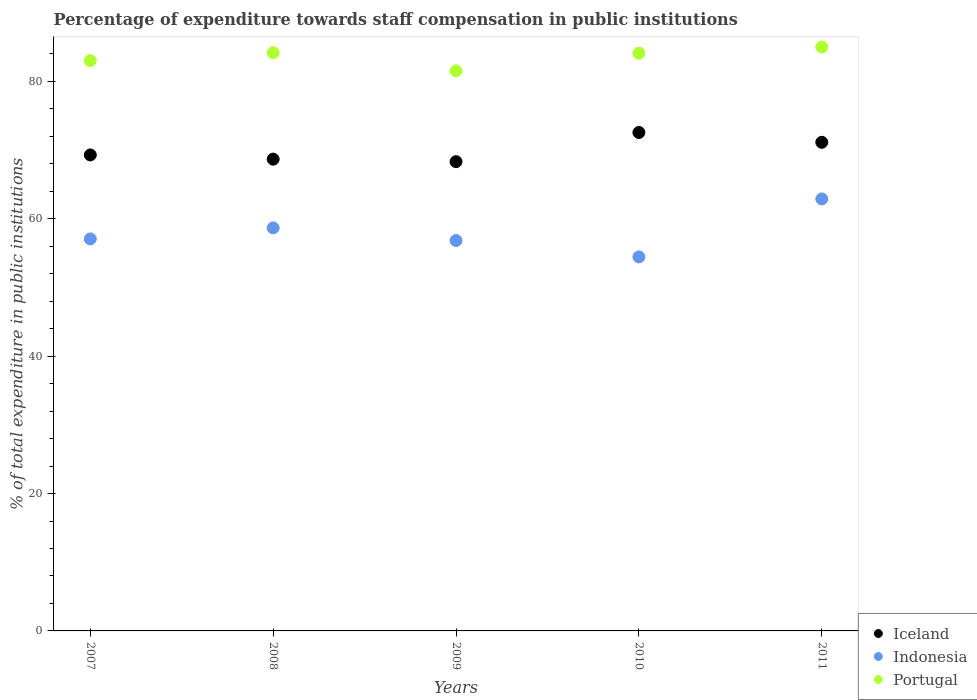What is the percentage of expenditure towards staff compensation in Portugal in 2007?
Your response must be concise. 83.03. Across all years, what is the maximum percentage of expenditure towards staff compensation in Portugal?
Offer a very short reply. 85. Across all years, what is the minimum percentage of expenditure towards staff compensation in Portugal?
Ensure brevity in your answer.  81.54. In which year was the percentage of expenditure towards staff compensation in Iceland maximum?
Keep it short and to the point. 2010. In which year was the percentage of expenditure towards staff compensation in Iceland minimum?
Give a very brief answer. 2009. What is the total percentage of expenditure towards staff compensation in Indonesia in the graph?
Provide a succinct answer. 289.94. What is the difference between the percentage of expenditure towards staff compensation in Iceland in 2008 and that in 2010?
Make the answer very short. -3.88. What is the difference between the percentage of expenditure towards staff compensation in Indonesia in 2011 and the percentage of expenditure towards staff compensation in Portugal in 2009?
Offer a terse response. -18.64. What is the average percentage of expenditure towards staff compensation in Portugal per year?
Offer a terse response. 83.57. In the year 2010, what is the difference between the percentage of expenditure towards staff compensation in Portugal and percentage of expenditure towards staff compensation in Iceland?
Keep it short and to the point. 11.54. In how many years, is the percentage of expenditure towards staff compensation in Iceland greater than 16 %?
Ensure brevity in your answer.  5. What is the ratio of the percentage of expenditure towards staff compensation in Iceland in 2008 to that in 2010?
Provide a short and direct response. 0.95. Is the percentage of expenditure towards staff compensation in Iceland in 2008 less than that in 2009?
Give a very brief answer. No. What is the difference between the highest and the second highest percentage of expenditure towards staff compensation in Iceland?
Keep it short and to the point. 1.43. What is the difference between the highest and the lowest percentage of expenditure towards staff compensation in Iceland?
Your response must be concise. 4.25. Is the percentage of expenditure towards staff compensation in Portugal strictly less than the percentage of expenditure towards staff compensation in Indonesia over the years?
Give a very brief answer. No. How many years are there in the graph?
Give a very brief answer. 5. What is the difference between two consecutive major ticks on the Y-axis?
Your answer should be compact. 20. Are the values on the major ticks of Y-axis written in scientific E-notation?
Provide a succinct answer. No. Does the graph contain grids?
Give a very brief answer. No. How are the legend labels stacked?
Give a very brief answer. Vertical. What is the title of the graph?
Your answer should be very brief. Percentage of expenditure towards staff compensation in public institutions. What is the label or title of the Y-axis?
Your answer should be very brief. % of total expenditure in public institutions. What is the % of total expenditure in public institutions in Iceland in 2007?
Offer a very short reply. 69.3. What is the % of total expenditure in public institutions of Indonesia in 2007?
Give a very brief answer. 57.07. What is the % of total expenditure in public institutions in Portugal in 2007?
Give a very brief answer. 83.03. What is the % of total expenditure in public institutions in Iceland in 2008?
Give a very brief answer. 68.69. What is the % of total expenditure in public institutions in Indonesia in 2008?
Keep it short and to the point. 58.68. What is the % of total expenditure in public institutions in Portugal in 2008?
Keep it short and to the point. 84.18. What is the % of total expenditure in public institutions of Iceland in 2009?
Give a very brief answer. 68.32. What is the % of total expenditure in public institutions in Indonesia in 2009?
Your answer should be very brief. 56.84. What is the % of total expenditure in public institutions in Portugal in 2009?
Ensure brevity in your answer.  81.54. What is the % of total expenditure in public institutions of Iceland in 2010?
Provide a short and direct response. 72.57. What is the % of total expenditure in public institutions in Indonesia in 2010?
Keep it short and to the point. 54.45. What is the % of total expenditure in public institutions in Portugal in 2010?
Offer a very short reply. 84.11. What is the % of total expenditure in public institutions of Iceland in 2011?
Your answer should be compact. 71.14. What is the % of total expenditure in public institutions of Indonesia in 2011?
Offer a terse response. 62.89. What is the % of total expenditure in public institutions of Portugal in 2011?
Offer a terse response. 85. Across all years, what is the maximum % of total expenditure in public institutions of Iceland?
Make the answer very short. 72.57. Across all years, what is the maximum % of total expenditure in public institutions of Indonesia?
Provide a succinct answer. 62.89. Across all years, what is the maximum % of total expenditure in public institutions in Portugal?
Offer a very short reply. 85. Across all years, what is the minimum % of total expenditure in public institutions of Iceland?
Offer a terse response. 68.32. Across all years, what is the minimum % of total expenditure in public institutions of Indonesia?
Make the answer very short. 54.45. Across all years, what is the minimum % of total expenditure in public institutions of Portugal?
Offer a very short reply. 81.54. What is the total % of total expenditure in public institutions of Iceland in the graph?
Make the answer very short. 350.01. What is the total % of total expenditure in public institutions in Indonesia in the graph?
Offer a terse response. 289.94. What is the total % of total expenditure in public institutions in Portugal in the graph?
Provide a short and direct response. 417.86. What is the difference between the % of total expenditure in public institutions of Iceland in 2007 and that in 2008?
Your answer should be very brief. 0.61. What is the difference between the % of total expenditure in public institutions in Indonesia in 2007 and that in 2008?
Your answer should be compact. -1.61. What is the difference between the % of total expenditure in public institutions in Portugal in 2007 and that in 2008?
Offer a terse response. -1.15. What is the difference between the % of total expenditure in public institutions in Iceland in 2007 and that in 2009?
Your answer should be very brief. 0.98. What is the difference between the % of total expenditure in public institutions in Indonesia in 2007 and that in 2009?
Your answer should be very brief. 0.23. What is the difference between the % of total expenditure in public institutions in Portugal in 2007 and that in 2009?
Make the answer very short. 1.49. What is the difference between the % of total expenditure in public institutions in Iceland in 2007 and that in 2010?
Offer a terse response. -3.27. What is the difference between the % of total expenditure in public institutions of Indonesia in 2007 and that in 2010?
Provide a succinct answer. 2.62. What is the difference between the % of total expenditure in public institutions in Portugal in 2007 and that in 2010?
Your answer should be very brief. -1.08. What is the difference between the % of total expenditure in public institutions of Iceland in 2007 and that in 2011?
Give a very brief answer. -1.84. What is the difference between the % of total expenditure in public institutions in Indonesia in 2007 and that in 2011?
Offer a terse response. -5.82. What is the difference between the % of total expenditure in public institutions of Portugal in 2007 and that in 2011?
Make the answer very short. -1.97. What is the difference between the % of total expenditure in public institutions in Iceland in 2008 and that in 2009?
Make the answer very short. 0.37. What is the difference between the % of total expenditure in public institutions in Indonesia in 2008 and that in 2009?
Keep it short and to the point. 1.84. What is the difference between the % of total expenditure in public institutions of Portugal in 2008 and that in 2009?
Offer a very short reply. 2.65. What is the difference between the % of total expenditure in public institutions of Iceland in 2008 and that in 2010?
Ensure brevity in your answer.  -3.88. What is the difference between the % of total expenditure in public institutions of Indonesia in 2008 and that in 2010?
Your answer should be compact. 4.23. What is the difference between the % of total expenditure in public institutions of Portugal in 2008 and that in 2010?
Make the answer very short. 0.07. What is the difference between the % of total expenditure in public institutions of Iceland in 2008 and that in 2011?
Offer a terse response. -2.45. What is the difference between the % of total expenditure in public institutions in Indonesia in 2008 and that in 2011?
Offer a terse response. -4.21. What is the difference between the % of total expenditure in public institutions in Portugal in 2008 and that in 2011?
Your answer should be very brief. -0.82. What is the difference between the % of total expenditure in public institutions of Iceland in 2009 and that in 2010?
Your answer should be compact. -4.25. What is the difference between the % of total expenditure in public institutions of Indonesia in 2009 and that in 2010?
Your answer should be compact. 2.39. What is the difference between the % of total expenditure in public institutions in Portugal in 2009 and that in 2010?
Offer a very short reply. -2.57. What is the difference between the % of total expenditure in public institutions of Iceland in 2009 and that in 2011?
Keep it short and to the point. -2.82. What is the difference between the % of total expenditure in public institutions in Indonesia in 2009 and that in 2011?
Make the answer very short. -6.05. What is the difference between the % of total expenditure in public institutions of Portugal in 2009 and that in 2011?
Provide a short and direct response. -3.47. What is the difference between the % of total expenditure in public institutions of Iceland in 2010 and that in 2011?
Keep it short and to the point. 1.43. What is the difference between the % of total expenditure in public institutions of Indonesia in 2010 and that in 2011?
Ensure brevity in your answer.  -8.44. What is the difference between the % of total expenditure in public institutions of Portugal in 2010 and that in 2011?
Provide a short and direct response. -0.89. What is the difference between the % of total expenditure in public institutions of Iceland in 2007 and the % of total expenditure in public institutions of Indonesia in 2008?
Offer a terse response. 10.62. What is the difference between the % of total expenditure in public institutions in Iceland in 2007 and the % of total expenditure in public institutions in Portugal in 2008?
Give a very brief answer. -14.88. What is the difference between the % of total expenditure in public institutions of Indonesia in 2007 and the % of total expenditure in public institutions of Portugal in 2008?
Provide a succinct answer. -27.11. What is the difference between the % of total expenditure in public institutions in Iceland in 2007 and the % of total expenditure in public institutions in Indonesia in 2009?
Offer a very short reply. 12.46. What is the difference between the % of total expenditure in public institutions in Iceland in 2007 and the % of total expenditure in public institutions in Portugal in 2009?
Keep it short and to the point. -12.24. What is the difference between the % of total expenditure in public institutions in Indonesia in 2007 and the % of total expenditure in public institutions in Portugal in 2009?
Keep it short and to the point. -24.46. What is the difference between the % of total expenditure in public institutions in Iceland in 2007 and the % of total expenditure in public institutions in Indonesia in 2010?
Make the answer very short. 14.85. What is the difference between the % of total expenditure in public institutions of Iceland in 2007 and the % of total expenditure in public institutions of Portugal in 2010?
Provide a succinct answer. -14.81. What is the difference between the % of total expenditure in public institutions of Indonesia in 2007 and the % of total expenditure in public institutions of Portugal in 2010?
Keep it short and to the point. -27.04. What is the difference between the % of total expenditure in public institutions in Iceland in 2007 and the % of total expenditure in public institutions in Indonesia in 2011?
Give a very brief answer. 6.41. What is the difference between the % of total expenditure in public institutions of Iceland in 2007 and the % of total expenditure in public institutions of Portugal in 2011?
Your response must be concise. -15.7. What is the difference between the % of total expenditure in public institutions in Indonesia in 2007 and the % of total expenditure in public institutions in Portugal in 2011?
Offer a terse response. -27.93. What is the difference between the % of total expenditure in public institutions of Iceland in 2008 and the % of total expenditure in public institutions of Indonesia in 2009?
Your answer should be compact. 11.85. What is the difference between the % of total expenditure in public institutions in Iceland in 2008 and the % of total expenditure in public institutions in Portugal in 2009?
Your response must be concise. -12.85. What is the difference between the % of total expenditure in public institutions of Indonesia in 2008 and the % of total expenditure in public institutions of Portugal in 2009?
Offer a very short reply. -22.86. What is the difference between the % of total expenditure in public institutions in Iceland in 2008 and the % of total expenditure in public institutions in Indonesia in 2010?
Give a very brief answer. 14.23. What is the difference between the % of total expenditure in public institutions in Iceland in 2008 and the % of total expenditure in public institutions in Portugal in 2010?
Offer a very short reply. -15.42. What is the difference between the % of total expenditure in public institutions of Indonesia in 2008 and the % of total expenditure in public institutions of Portugal in 2010?
Give a very brief answer. -25.43. What is the difference between the % of total expenditure in public institutions in Iceland in 2008 and the % of total expenditure in public institutions in Indonesia in 2011?
Offer a very short reply. 5.79. What is the difference between the % of total expenditure in public institutions in Iceland in 2008 and the % of total expenditure in public institutions in Portugal in 2011?
Offer a terse response. -16.32. What is the difference between the % of total expenditure in public institutions in Indonesia in 2008 and the % of total expenditure in public institutions in Portugal in 2011?
Your response must be concise. -26.32. What is the difference between the % of total expenditure in public institutions in Iceland in 2009 and the % of total expenditure in public institutions in Indonesia in 2010?
Your response must be concise. 13.87. What is the difference between the % of total expenditure in public institutions in Iceland in 2009 and the % of total expenditure in public institutions in Portugal in 2010?
Provide a short and direct response. -15.79. What is the difference between the % of total expenditure in public institutions of Indonesia in 2009 and the % of total expenditure in public institutions of Portugal in 2010?
Your answer should be compact. -27.27. What is the difference between the % of total expenditure in public institutions of Iceland in 2009 and the % of total expenditure in public institutions of Indonesia in 2011?
Offer a very short reply. 5.43. What is the difference between the % of total expenditure in public institutions of Iceland in 2009 and the % of total expenditure in public institutions of Portugal in 2011?
Keep it short and to the point. -16.68. What is the difference between the % of total expenditure in public institutions of Indonesia in 2009 and the % of total expenditure in public institutions of Portugal in 2011?
Keep it short and to the point. -28.16. What is the difference between the % of total expenditure in public institutions of Iceland in 2010 and the % of total expenditure in public institutions of Indonesia in 2011?
Provide a short and direct response. 9.68. What is the difference between the % of total expenditure in public institutions in Iceland in 2010 and the % of total expenditure in public institutions in Portugal in 2011?
Provide a succinct answer. -12.43. What is the difference between the % of total expenditure in public institutions in Indonesia in 2010 and the % of total expenditure in public institutions in Portugal in 2011?
Your response must be concise. -30.55. What is the average % of total expenditure in public institutions of Iceland per year?
Your answer should be very brief. 70. What is the average % of total expenditure in public institutions in Indonesia per year?
Ensure brevity in your answer.  57.99. What is the average % of total expenditure in public institutions in Portugal per year?
Your answer should be compact. 83.57. In the year 2007, what is the difference between the % of total expenditure in public institutions in Iceland and % of total expenditure in public institutions in Indonesia?
Make the answer very short. 12.23. In the year 2007, what is the difference between the % of total expenditure in public institutions in Iceland and % of total expenditure in public institutions in Portugal?
Your answer should be compact. -13.73. In the year 2007, what is the difference between the % of total expenditure in public institutions in Indonesia and % of total expenditure in public institutions in Portugal?
Make the answer very short. -25.96. In the year 2008, what is the difference between the % of total expenditure in public institutions in Iceland and % of total expenditure in public institutions in Indonesia?
Offer a terse response. 10. In the year 2008, what is the difference between the % of total expenditure in public institutions in Iceland and % of total expenditure in public institutions in Portugal?
Provide a succinct answer. -15.5. In the year 2008, what is the difference between the % of total expenditure in public institutions of Indonesia and % of total expenditure in public institutions of Portugal?
Make the answer very short. -25.5. In the year 2009, what is the difference between the % of total expenditure in public institutions of Iceland and % of total expenditure in public institutions of Indonesia?
Provide a short and direct response. 11.48. In the year 2009, what is the difference between the % of total expenditure in public institutions of Iceland and % of total expenditure in public institutions of Portugal?
Offer a very short reply. -13.22. In the year 2009, what is the difference between the % of total expenditure in public institutions of Indonesia and % of total expenditure in public institutions of Portugal?
Provide a succinct answer. -24.7. In the year 2010, what is the difference between the % of total expenditure in public institutions of Iceland and % of total expenditure in public institutions of Indonesia?
Your response must be concise. 18.12. In the year 2010, what is the difference between the % of total expenditure in public institutions of Iceland and % of total expenditure in public institutions of Portugal?
Offer a very short reply. -11.54. In the year 2010, what is the difference between the % of total expenditure in public institutions in Indonesia and % of total expenditure in public institutions in Portugal?
Ensure brevity in your answer.  -29.66. In the year 2011, what is the difference between the % of total expenditure in public institutions in Iceland and % of total expenditure in public institutions in Indonesia?
Ensure brevity in your answer.  8.24. In the year 2011, what is the difference between the % of total expenditure in public institutions of Iceland and % of total expenditure in public institutions of Portugal?
Offer a terse response. -13.87. In the year 2011, what is the difference between the % of total expenditure in public institutions of Indonesia and % of total expenditure in public institutions of Portugal?
Keep it short and to the point. -22.11. What is the ratio of the % of total expenditure in public institutions of Indonesia in 2007 to that in 2008?
Keep it short and to the point. 0.97. What is the ratio of the % of total expenditure in public institutions of Portugal in 2007 to that in 2008?
Offer a terse response. 0.99. What is the ratio of the % of total expenditure in public institutions in Iceland in 2007 to that in 2009?
Ensure brevity in your answer.  1.01. What is the ratio of the % of total expenditure in public institutions in Indonesia in 2007 to that in 2009?
Provide a short and direct response. 1. What is the ratio of the % of total expenditure in public institutions of Portugal in 2007 to that in 2009?
Give a very brief answer. 1.02. What is the ratio of the % of total expenditure in public institutions in Iceland in 2007 to that in 2010?
Make the answer very short. 0.95. What is the ratio of the % of total expenditure in public institutions in Indonesia in 2007 to that in 2010?
Your answer should be very brief. 1.05. What is the ratio of the % of total expenditure in public institutions of Portugal in 2007 to that in 2010?
Provide a short and direct response. 0.99. What is the ratio of the % of total expenditure in public institutions in Iceland in 2007 to that in 2011?
Give a very brief answer. 0.97. What is the ratio of the % of total expenditure in public institutions in Indonesia in 2007 to that in 2011?
Ensure brevity in your answer.  0.91. What is the ratio of the % of total expenditure in public institutions of Portugal in 2007 to that in 2011?
Give a very brief answer. 0.98. What is the ratio of the % of total expenditure in public institutions of Iceland in 2008 to that in 2009?
Provide a succinct answer. 1.01. What is the ratio of the % of total expenditure in public institutions in Indonesia in 2008 to that in 2009?
Your answer should be compact. 1.03. What is the ratio of the % of total expenditure in public institutions of Portugal in 2008 to that in 2009?
Offer a very short reply. 1.03. What is the ratio of the % of total expenditure in public institutions of Iceland in 2008 to that in 2010?
Offer a very short reply. 0.95. What is the ratio of the % of total expenditure in public institutions of Indonesia in 2008 to that in 2010?
Ensure brevity in your answer.  1.08. What is the ratio of the % of total expenditure in public institutions in Iceland in 2008 to that in 2011?
Keep it short and to the point. 0.97. What is the ratio of the % of total expenditure in public institutions in Indonesia in 2008 to that in 2011?
Offer a terse response. 0.93. What is the ratio of the % of total expenditure in public institutions of Portugal in 2008 to that in 2011?
Keep it short and to the point. 0.99. What is the ratio of the % of total expenditure in public institutions of Iceland in 2009 to that in 2010?
Offer a very short reply. 0.94. What is the ratio of the % of total expenditure in public institutions in Indonesia in 2009 to that in 2010?
Offer a very short reply. 1.04. What is the ratio of the % of total expenditure in public institutions of Portugal in 2009 to that in 2010?
Your response must be concise. 0.97. What is the ratio of the % of total expenditure in public institutions in Iceland in 2009 to that in 2011?
Ensure brevity in your answer.  0.96. What is the ratio of the % of total expenditure in public institutions of Indonesia in 2009 to that in 2011?
Give a very brief answer. 0.9. What is the ratio of the % of total expenditure in public institutions in Portugal in 2009 to that in 2011?
Your response must be concise. 0.96. What is the ratio of the % of total expenditure in public institutions of Iceland in 2010 to that in 2011?
Make the answer very short. 1.02. What is the ratio of the % of total expenditure in public institutions of Indonesia in 2010 to that in 2011?
Your answer should be compact. 0.87. What is the ratio of the % of total expenditure in public institutions of Portugal in 2010 to that in 2011?
Offer a very short reply. 0.99. What is the difference between the highest and the second highest % of total expenditure in public institutions of Iceland?
Ensure brevity in your answer.  1.43. What is the difference between the highest and the second highest % of total expenditure in public institutions of Indonesia?
Your answer should be compact. 4.21. What is the difference between the highest and the second highest % of total expenditure in public institutions in Portugal?
Your answer should be compact. 0.82. What is the difference between the highest and the lowest % of total expenditure in public institutions in Iceland?
Offer a very short reply. 4.25. What is the difference between the highest and the lowest % of total expenditure in public institutions in Indonesia?
Give a very brief answer. 8.44. What is the difference between the highest and the lowest % of total expenditure in public institutions of Portugal?
Offer a terse response. 3.47. 